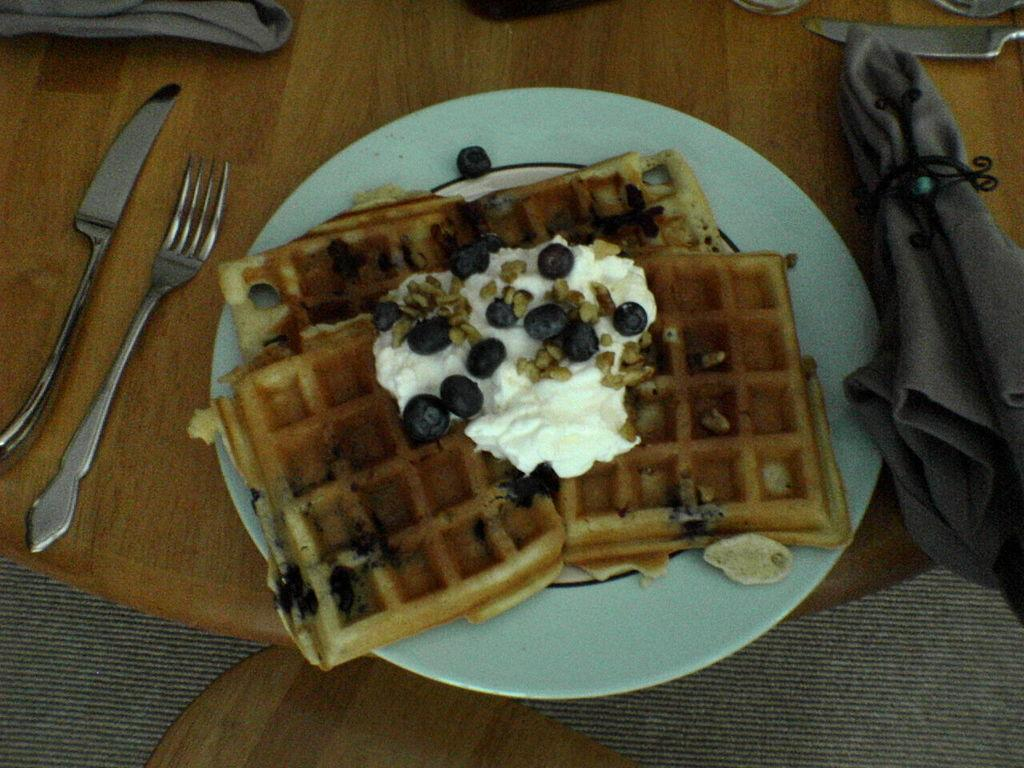What is on the plate that is visible in the image? There is food on a plate in the image. What utensils are present in the image? There is a knife and a fork in the image. What type of material is the cloth in the image made of? The cloth in the image is not specified, but it is present. What is on the table in the image? There are table mats on the table in the image. Can you see any corn growing on the table in the image? There is no corn growing on the table in the image. Is there a skateboard visible in the image? There is no skateboard present in the image. 